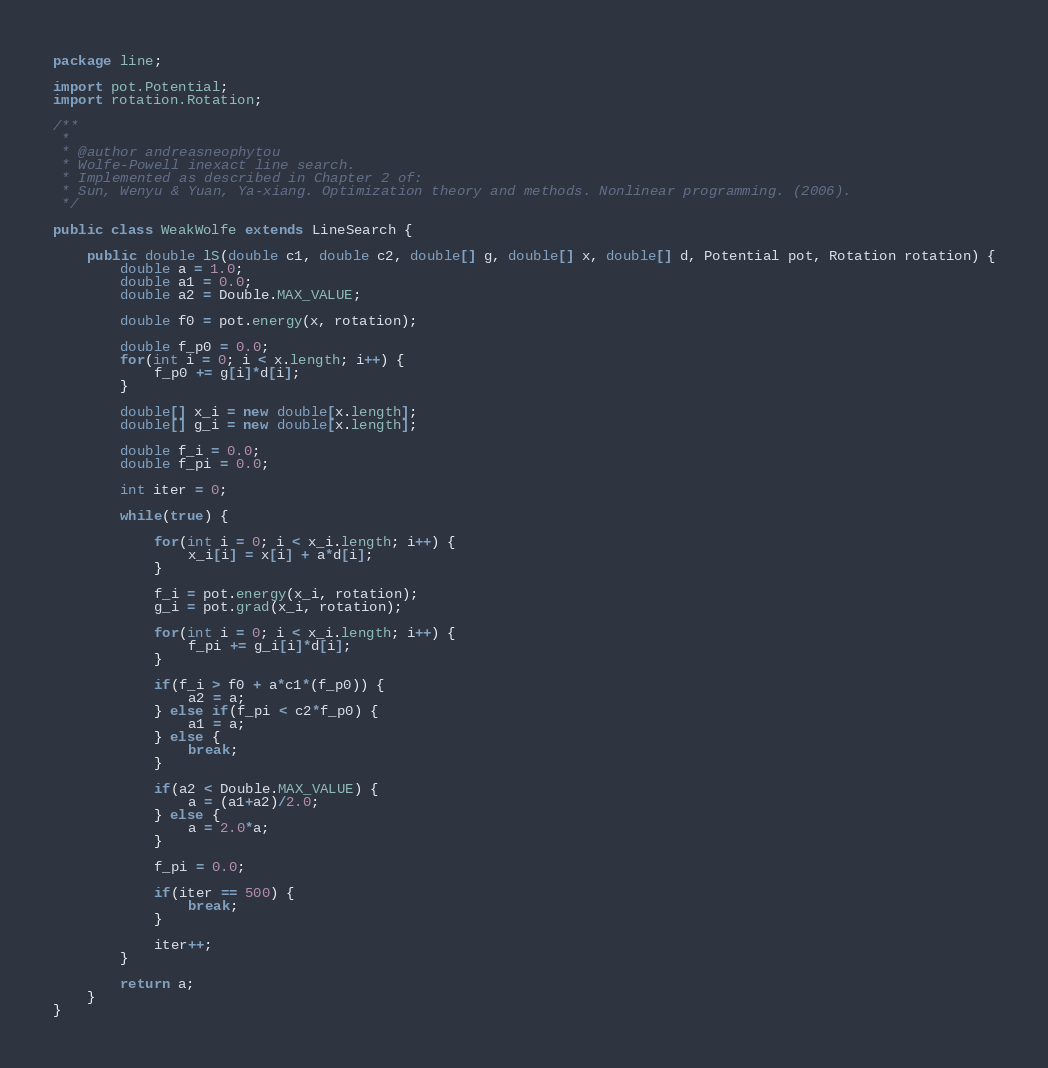Convert code to text. <code><loc_0><loc_0><loc_500><loc_500><_Java_>package line;

import pot.Potential;
import rotation.Rotation;

/**
 * 
 * @author andreasneophytou
 * Wolfe-Powell inexact line search. 
 * Implemented as described in Chapter 2 of:
 * Sun, Wenyu & Yuan, Ya-xiang. Optimization theory and methods. Nonlinear programming. (2006).
 */

public class WeakWolfe extends LineSearch {
	
	public double lS(double c1, double c2, double[] g, double[] x, double[] d, Potential pot, Rotation rotation) {
		double a = 1.0;
		double a1 = 0.0;
		double a2 = Double.MAX_VALUE;
	
		double f0 = pot.energy(x, rotation);
		
		double f_p0 = 0.0;
		for(int i = 0; i < x.length; i++) {
			f_p0 += g[i]*d[i]; 
		}
		
		double[] x_i = new double[x.length];
		double[] g_i = new double[x.length];
		
		double f_i = 0.0;
		double f_pi = 0.0;
		
		int iter = 0;
		
		while(true) {
			
			for(int i = 0; i < x_i.length; i++) {
				x_i[i] = x[i] + a*d[i];
			}
			
			f_i = pot.energy(x_i, rotation);
			g_i = pot.grad(x_i, rotation);
			
			for(int i = 0; i < x_i.length; i++) {
				f_pi += g_i[i]*d[i]; 
			}
			
			if(f_i > f0 + a*c1*(f_p0)) {
				a2 = a;
			} else if(f_pi < c2*f_p0) {
				a1 = a;
			} else {
				break;
			}
			
			if(a2 < Double.MAX_VALUE) {
				a = (a1+a2)/2.0;
			} else {
				a = 2.0*a;
			}	
			
			f_pi = 0.0;
			
			if(iter == 500) {
				break;
			}
			
			iter++;
		}
		
		return a;
	}
}
</code> 